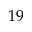<formula> <loc_0><loc_0><loc_500><loc_500>1 9</formula> 